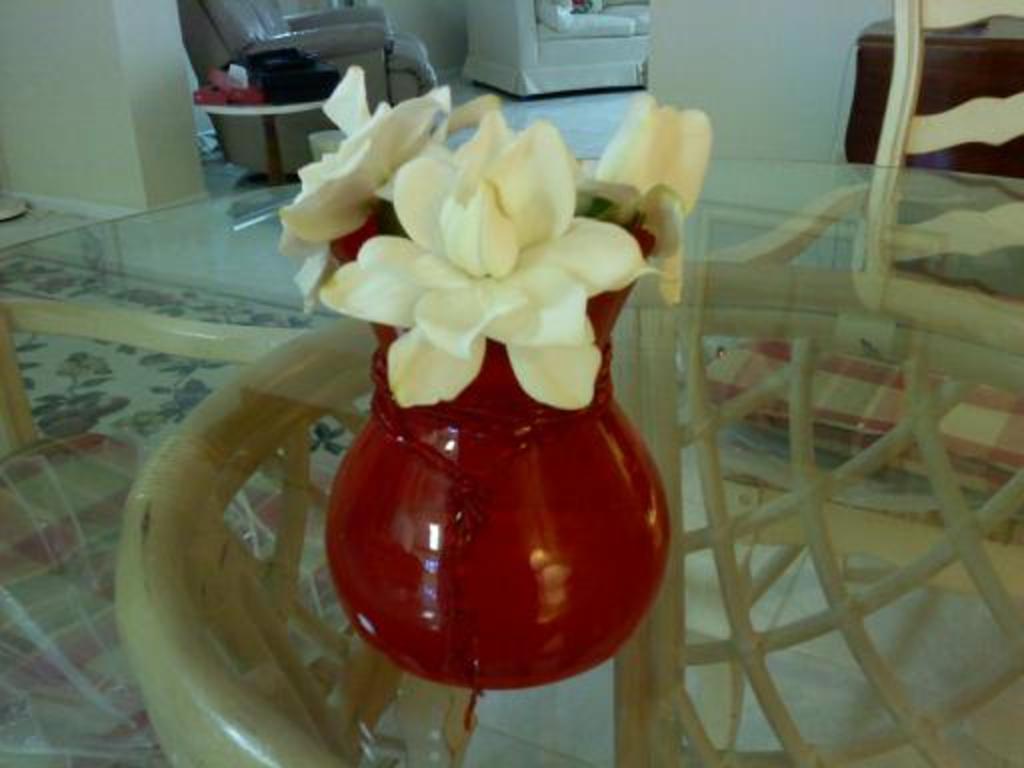How would you summarize this image in a sentence or two? In this image, we can see a flower vase that is placed on a glass table. Floor we can see. Wooden chair. The back side we can see a chairs and table. Few items are placed on it. Cream color wall. Left side ,There is a floor mat. 